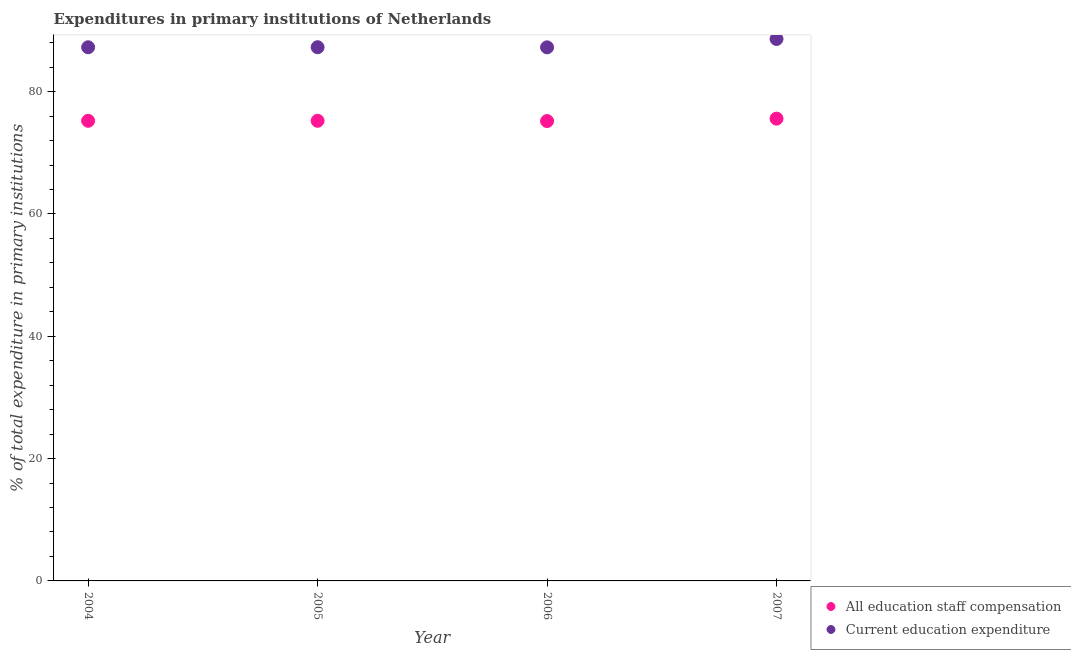How many different coloured dotlines are there?
Provide a succinct answer. 2. Is the number of dotlines equal to the number of legend labels?
Your response must be concise. Yes. What is the expenditure in education in 2004?
Make the answer very short. 87.25. Across all years, what is the maximum expenditure in education?
Make the answer very short. 88.61. Across all years, what is the minimum expenditure in education?
Provide a succinct answer. 87.24. What is the total expenditure in education in the graph?
Your answer should be compact. 350.36. What is the difference between the expenditure in education in 2005 and that in 2007?
Keep it short and to the point. -1.35. What is the difference between the expenditure in education in 2006 and the expenditure in staff compensation in 2005?
Ensure brevity in your answer.  12.01. What is the average expenditure in education per year?
Make the answer very short. 87.59. In the year 2006, what is the difference between the expenditure in staff compensation and expenditure in education?
Your answer should be very brief. -12.05. In how many years, is the expenditure in education greater than 20 %?
Offer a terse response. 4. What is the ratio of the expenditure in staff compensation in 2004 to that in 2005?
Your answer should be compact. 1. Is the difference between the expenditure in staff compensation in 2005 and 2006 greater than the difference between the expenditure in education in 2005 and 2006?
Make the answer very short. Yes. What is the difference between the highest and the second highest expenditure in staff compensation?
Your answer should be compact. 0.35. What is the difference between the highest and the lowest expenditure in education?
Your answer should be very brief. 1.37. Is the expenditure in staff compensation strictly greater than the expenditure in education over the years?
Provide a succinct answer. No. Is the expenditure in education strictly less than the expenditure in staff compensation over the years?
Provide a succinct answer. No. How many years are there in the graph?
Offer a terse response. 4. What is the difference between two consecutive major ticks on the Y-axis?
Offer a terse response. 20. Does the graph contain any zero values?
Offer a very short reply. No. Does the graph contain grids?
Ensure brevity in your answer.  No. What is the title of the graph?
Your response must be concise. Expenditures in primary institutions of Netherlands. What is the label or title of the X-axis?
Ensure brevity in your answer.  Year. What is the label or title of the Y-axis?
Provide a succinct answer. % of total expenditure in primary institutions. What is the % of total expenditure in primary institutions of All education staff compensation in 2004?
Keep it short and to the point. 75.23. What is the % of total expenditure in primary institutions of Current education expenditure in 2004?
Your answer should be compact. 87.25. What is the % of total expenditure in primary institutions in All education staff compensation in 2005?
Your response must be concise. 75.23. What is the % of total expenditure in primary institutions of Current education expenditure in 2005?
Your answer should be very brief. 87.26. What is the % of total expenditure in primary institutions in All education staff compensation in 2006?
Your response must be concise. 75.19. What is the % of total expenditure in primary institutions of Current education expenditure in 2006?
Your response must be concise. 87.24. What is the % of total expenditure in primary institutions of All education staff compensation in 2007?
Offer a terse response. 75.58. What is the % of total expenditure in primary institutions in Current education expenditure in 2007?
Your answer should be compact. 88.61. Across all years, what is the maximum % of total expenditure in primary institutions of All education staff compensation?
Provide a succinct answer. 75.58. Across all years, what is the maximum % of total expenditure in primary institutions of Current education expenditure?
Offer a very short reply. 88.61. Across all years, what is the minimum % of total expenditure in primary institutions in All education staff compensation?
Your answer should be very brief. 75.19. Across all years, what is the minimum % of total expenditure in primary institutions of Current education expenditure?
Keep it short and to the point. 87.24. What is the total % of total expenditure in primary institutions of All education staff compensation in the graph?
Give a very brief answer. 301.23. What is the total % of total expenditure in primary institutions in Current education expenditure in the graph?
Offer a very short reply. 350.36. What is the difference between the % of total expenditure in primary institutions of All education staff compensation in 2004 and that in 2005?
Give a very brief answer. -0. What is the difference between the % of total expenditure in primary institutions of Current education expenditure in 2004 and that in 2005?
Ensure brevity in your answer.  -0.01. What is the difference between the % of total expenditure in primary institutions of All education staff compensation in 2004 and that in 2006?
Make the answer very short. 0.04. What is the difference between the % of total expenditure in primary institutions of Current education expenditure in 2004 and that in 2006?
Your response must be concise. 0.01. What is the difference between the % of total expenditure in primary institutions in All education staff compensation in 2004 and that in 2007?
Offer a very short reply. -0.35. What is the difference between the % of total expenditure in primary institutions of Current education expenditure in 2004 and that in 2007?
Offer a very short reply. -1.36. What is the difference between the % of total expenditure in primary institutions in All education staff compensation in 2005 and that in 2006?
Give a very brief answer. 0.04. What is the difference between the % of total expenditure in primary institutions in Current education expenditure in 2005 and that in 2006?
Provide a succinct answer. 0.02. What is the difference between the % of total expenditure in primary institutions of All education staff compensation in 2005 and that in 2007?
Your answer should be compact. -0.35. What is the difference between the % of total expenditure in primary institutions in Current education expenditure in 2005 and that in 2007?
Your response must be concise. -1.35. What is the difference between the % of total expenditure in primary institutions in All education staff compensation in 2006 and that in 2007?
Make the answer very short. -0.39. What is the difference between the % of total expenditure in primary institutions of Current education expenditure in 2006 and that in 2007?
Provide a succinct answer. -1.37. What is the difference between the % of total expenditure in primary institutions of All education staff compensation in 2004 and the % of total expenditure in primary institutions of Current education expenditure in 2005?
Ensure brevity in your answer.  -12.03. What is the difference between the % of total expenditure in primary institutions of All education staff compensation in 2004 and the % of total expenditure in primary institutions of Current education expenditure in 2006?
Your answer should be very brief. -12.01. What is the difference between the % of total expenditure in primary institutions in All education staff compensation in 2004 and the % of total expenditure in primary institutions in Current education expenditure in 2007?
Your response must be concise. -13.38. What is the difference between the % of total expenditure in primary institutions in All education staff compensation in 2005 and the % of total expenditure in primary institutions in Current education expenditure in 2006?
Ensure brevity in your answer.  -12.01. What is the difference between the % of total expenditure in primary institutions in All education staff compensation in 2005 and the % of total expenditure in primary institutions in Current education expenditure in 2007?
Keep it short and to the point. -13.38. What is the difference between the % of total expenditure in primary institutions of All education staff compensation in 2006 and the % of total expenditure in primary institutions of Current education expenditure in 2007?
Offer a terse response. -13.42. What is the average % of total expenditure in primary institutions in All education staff compensation per year?
Offer a very short reply. 75.31. What is the average % of total expenditure in primary institutions in Current education expenditure per year?
Make the answer very short. 87.59. In the year 2004, what is the difference between the % of total expenditure in primary institutions in All education staff compensation and % of total expenditure in primary institutions in Current education expenditure?
Give a very brief answer. -12.02. In the year 2005, what is the difference between the % of total expenditure in primary institutions in All education staff compensation and % of total expenditure in primary institutions in Current education expenditure?
Make the answer very short. -12.03. In the year 2006, what is the difference between the % of total expenditure in primary institutions of All education staff compensation and % of total expenditure in primary institutions of Current education expenditure?
Your response must be concise. -12.05. In the year 2007, what is the difference between the % of total expenditure in primary institutions in All education staff compensation and % of total expenditure in primary institutions in Current education expenditure?
Keep it short and to the point. -13.03. What is the ratio of the % of total expenditure in primary institutions in All education staff compensation in 2004 to that in 2005?
Your answer should be compact. 1. What is the ratio of the % of total expenditure in primary institutions in Current education expenditure in 2004 to that in 2005?
Provide a short and direct response. 1. What is the ratio of the % of total expenditure in primary institutions of All education staff compensation in 2004 to that in 2006?
Give a very brief answer. 1. What is the ratio of the % of total expenditure in primary institutions of All education staff compensation in 2004 to that in 2007?
Give a very brief answer. 1. What is the ratio of the % of total expenditure in primary institutions of Current education expenditure in 2004 to that in 2007?
Provide a short and direct response. 0.98. What is the ratio of the % of total expenditure in primary institutions in All education staff compensation in 2005 to that in 2006?
Your answer should be very brief. 1. What is the ratio of the % of total expenditure in primary institutions of All education staff compensation in 2006 to that in 2007?
Your answer should be compact. 0.99. What is the ratio of the % of total expenditure in primary institutions of Current education expenditure in 2006 to that in 2007?
Make the answer very short. 0.98. What is the difference between the highest and the second highest % of total expenditure in primary institutions in All education staff compensation?
Your answer should be very brief. 0.35. What is the difference between the highest and the second highest % of total expenditure in primary institutions of Current education expenditure?
Give a very brief answer. 1.35. What is the difference between the highest and the lowest % of total expenditure in primary institutions in All education staff compensation?
Provide a succinct answer. 0.39. What is the difference between the highest and the lowest % of total expenditure in primary institutions of Current education expenditure?
Your answer should be compact. 1.37. 